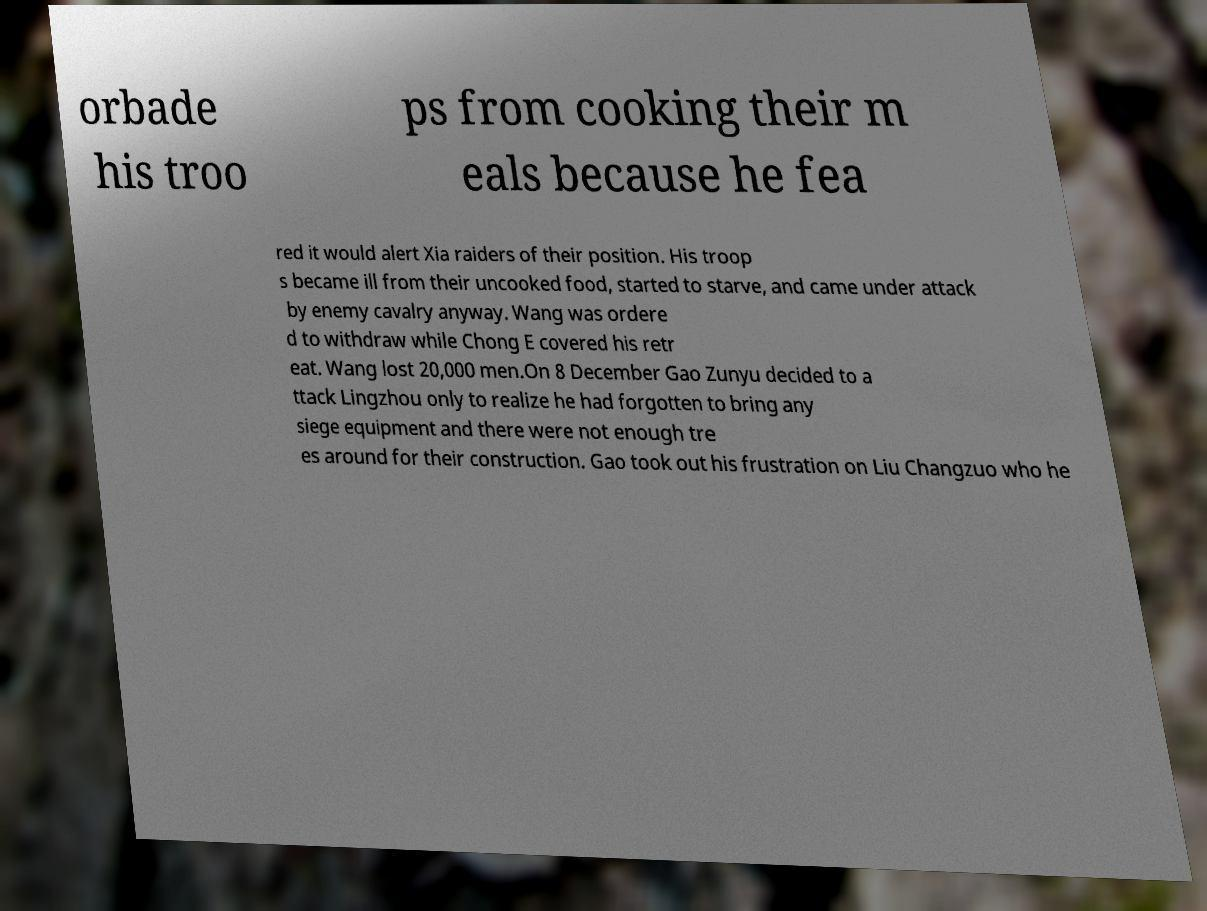For documentation purposes, I need the text within this image transcribed. Could you provide that? orbade his troo ps from cooking their m eals because he fea red it would alert Xia raiders of their position. His troop s became ill from their uncooked food, started to starve, and came under attack by enemy cavalry anyway. Wang was ordere d to withdraw while Chong E covered his retr eat. Wang lost 20,000 men.On 8 December Gao Zunyu decided to a ttack Lingzhou only to realize he had forgotten to bring any siege equipment and there were not enough tre es around for their construction. Gao took out his frustration on Liu Changzuo who he 